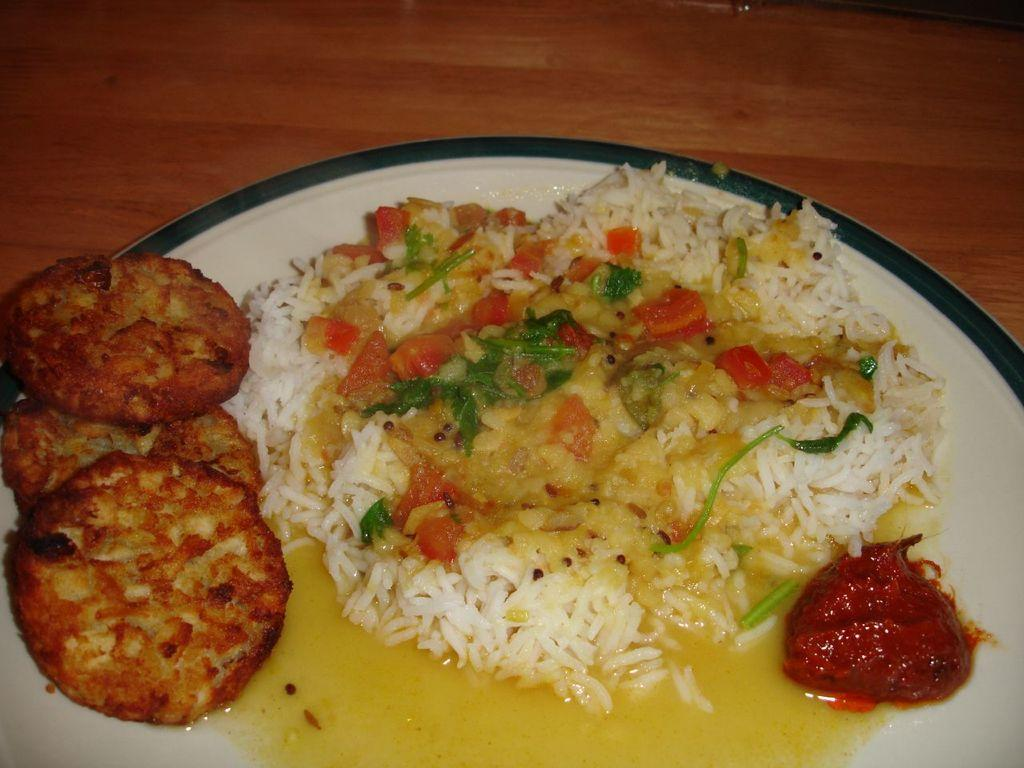What type of food is visible in the image? There is rice, curries, and chutney in the image. What is the color of the plate on which the food is served? The food is served on a white color plate. What type of toothbrush is used by the father in the image? There is no father or toothbrush present in the image. 